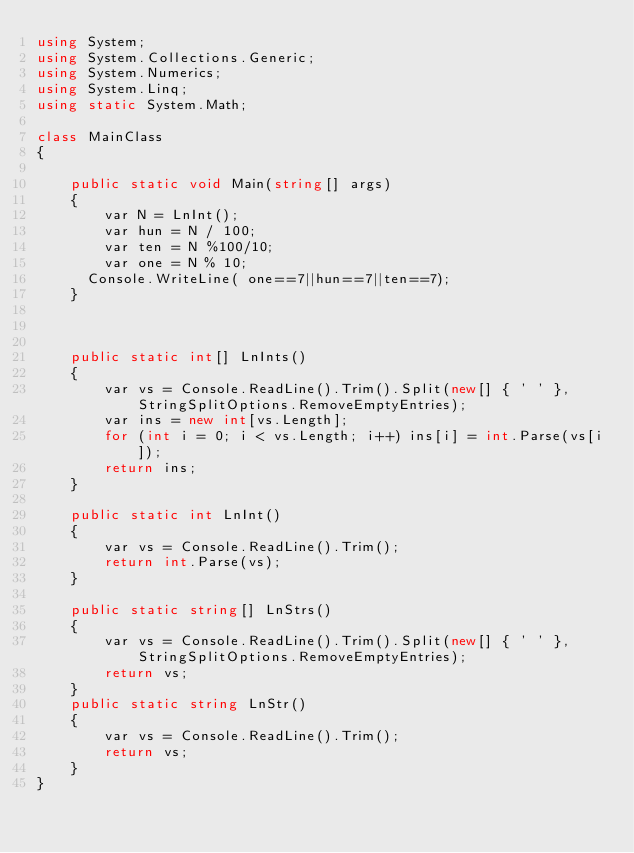<code> <loc_0><loc_0><loc_500><loc_500><_C#_>using System;
using System.Collections.Generic;
using System.Numerics;
using System.Linq;
using static System.Math;

class MainClass
{

    public static void Main(string[] args)
    {
        var N = LnInt();
        var hun = N / 100;
        var ten = N %100/10;
        var one = N % 10;
      Console.WriteLine( one==7||hun==7||ten==7);
    }



    public static int[] LnInts()
    {
        var vs = Console.ReadLine().Trim().Split(new[] { ' ' }, StringSplitOptions.RemoveEmptyEntries);
        var ins = new int[vs.Length];
        for (int i = 0; i < vs.Length; i++) ins[i] = int.Parse(vs[i]);
        return ins;
    }

    public static int LnInt()
    {
        var vs = Console.ReadLine().Trim();
        return int.Parse(vs);
    }

    public static string[] LnStrs()
    {
        var vs = Console.ReadLine().Trim().Split(new[] { ' ' }, StringSplitOptions.RemoveEmptyEntries);
        return vs;
    }
    public static string LnStr()
    {
        var vs = Console.ReadLine().Trim();
        return vs;
    }
}</code> 